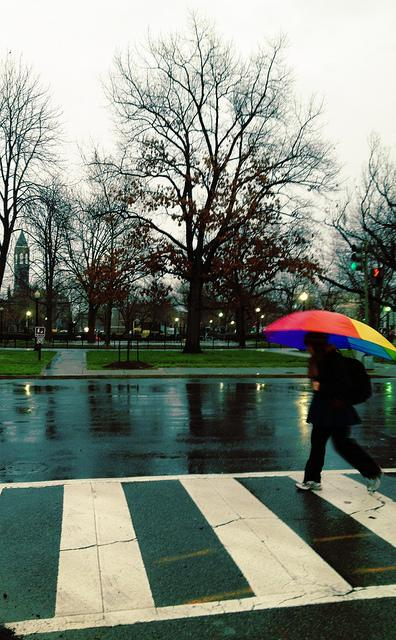What is the person walking on? crosswalk 